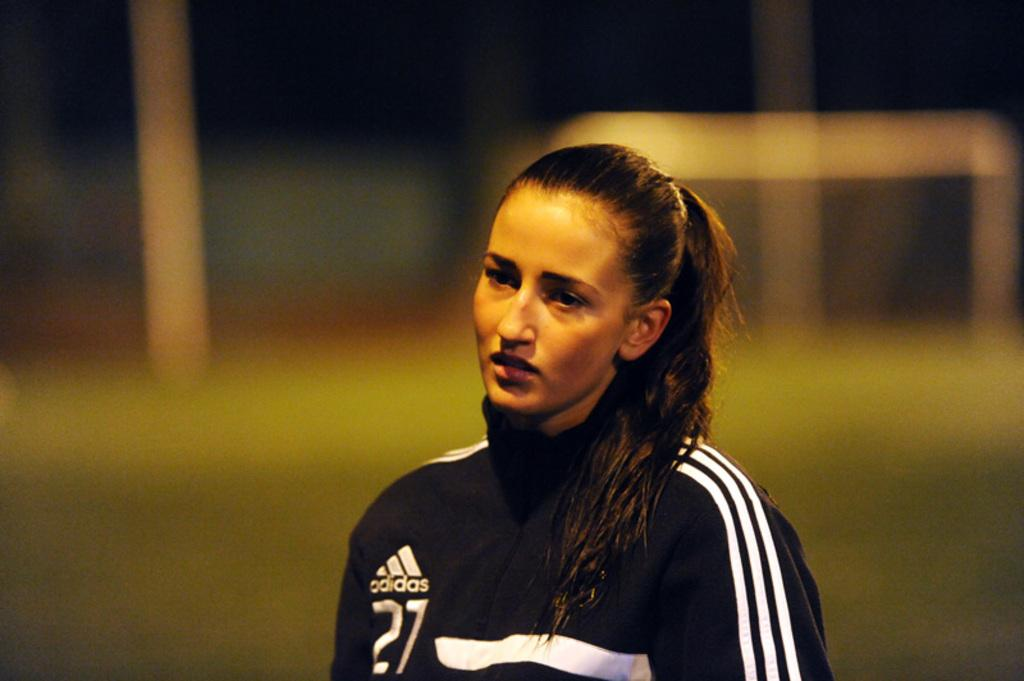Provide a one-sentence caption for the provided image. A woman has on a warm-up suit made by adidas. 